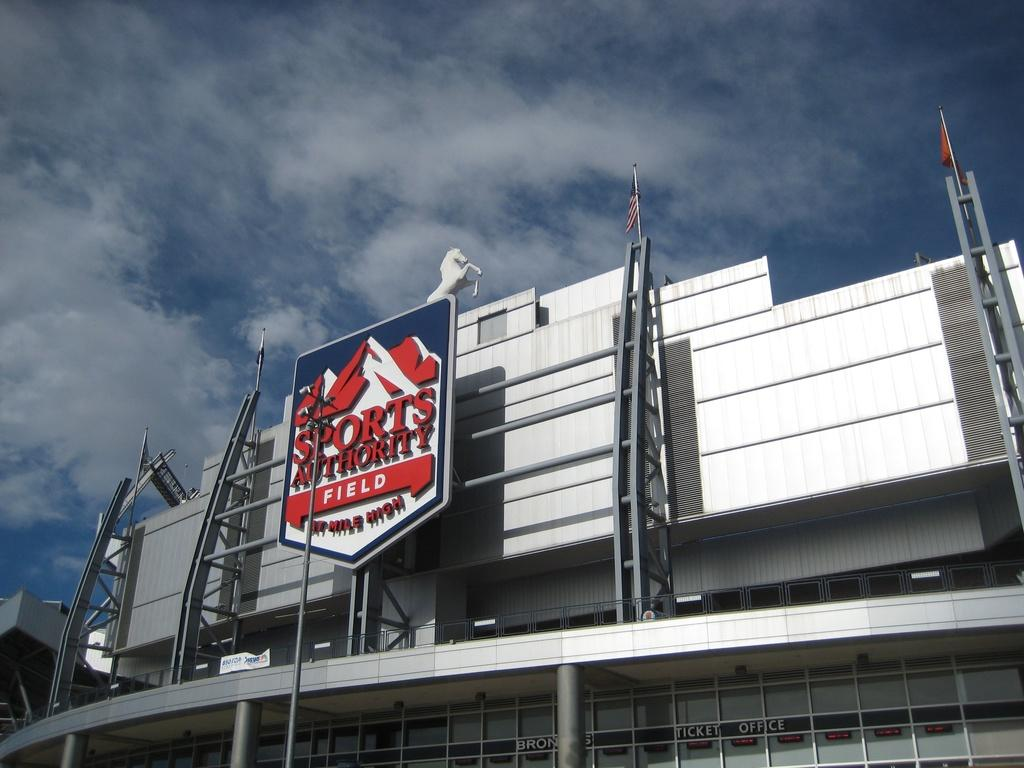What structure is the main subject of the image? There is a building in the image. What is on top of the building? There are flags on top of the building. What type of animal can be seen in the image? There is a depiction of a horse in the image. What is written or displayed on a flat surface in the image? There is a board with some text in the image. What can be seen in the background of the image? The sky is visible in the background of the image. Can you tell me how many waves are visible in the image? There are no waves present in the image; it features a building with flags, a depiction of a horse, a board with text, and a visible sky. What type of hill is shown in the image? There is no hill present in the image; it features a building with flags, a depiction of a horse, a board with text, and a visible sky. 